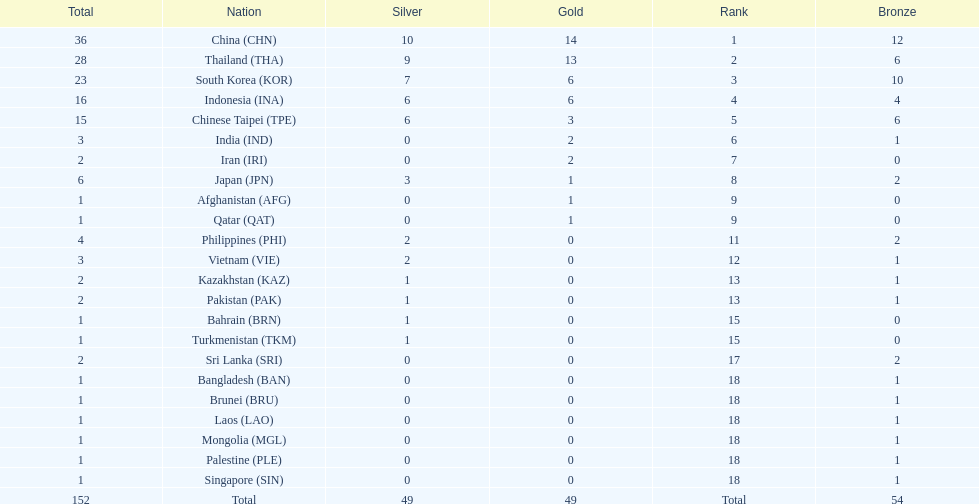What was the number of medals earned by indonesia (ina) ? 16. Parse the full table. {'header': ['Total', 'Nation', 'Silver', 'Gold', 'Rank', 'Bronze'], 'rows': [['36', 'China\xa0(CHN)', '10', '14', '1', '12'], ['28', 'Thailand\xa0(THA)', '9', '13', '2', '6'], ['23', 'South Korea\xa0(KOR)', '7', '6', '3', '10'], ['16', 'Indonesia\xa0(INA)', '6', '6', '4', '4'], ['15', 'Chinese Taipei\xa0(TPE)', '6', '3', '5', '6'], ['3', 'India\xa0(IND)', '0', '2', '6', '1'], ['2', 'Iran\xa0(IRI)', '0', '2', '7', '0'], ['6', 'Japan\xa0(JPN)', '3', '1', '8', '2'], ['1', 'Afghanistan\xa0(AFG)', '0', '1', '9', '0'], ['1', 'Qatar\xa0(QAT)', '0', '1', '9', '0'], ['4', 'Philippines\xa0(PHI)', '2', '0', '11', '2'], ['3', 'Vietnam\xa0(VIE)', '2', '0', '12', '1'], ['2', 'Kazakhstan\xa0(KAZ)', '1', '0', '13', '1'], ['2', 'Pakistan\xa0(PAK)', '1', '0', '13', '1'], ['1', 'Bahrain\xa0(BRN)', '1', '0', '15', '0'], ['1', 'Turkmenistan\xa0(TKM)', '1', '0', '15', '0'], ['2', 'Sri Lanka\xa0(SRI)', '0', '0', '17', '2'], ['1', 'Bangladesh\xa0(BAN)', '0', '0', '18', '1'], ['1', 'Brunei\xa0(BRU)', '0', '0', '18', '1'], ['1', 'Laos\xa0(LAO)', '0', '0', '18', '1'], ['1', 'Mongolia\xa0(MGL)', '0', '0', '18', '1'], ['1', 'Palestine\xa0(PLE)', '0', '0', '18', '1'], ['1', 'Singapore\xa0(SIN)', '0', '0', '18', '1'], ['152', 'Total', '49', '49', 'Total', '54']]} 